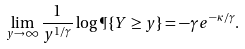<formula> <loc_0><loc_0><loc_500><loc_500>\lim _ { y \to \infty } \frac { 1 } { y ^ { 1 / \gamma } } \log \P \{ Y \geq y \} = - \gamma e ^ { - \kappa / \gamma } .</formula> 